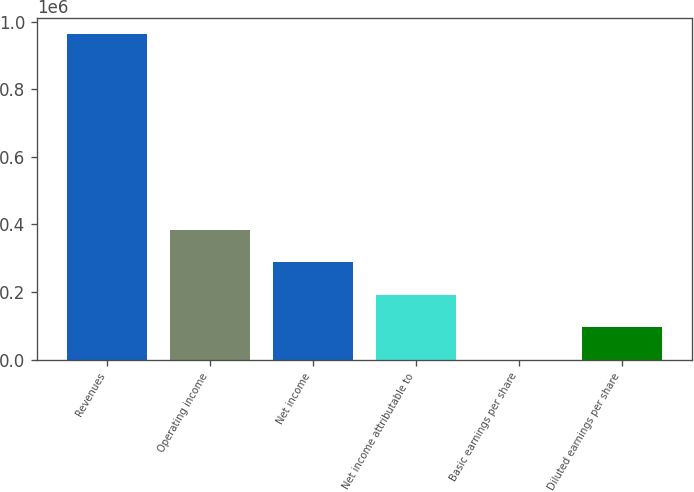Convert chart to OTSL. <chart><loc_0><loc_0><loc_500><loc_500><bar_chart><fcel>Revenues<fcel>Operating income<fcel>Net income<fcel>Net income attributable to<fcel>Basic earnings per share<fcel>Diluted earnings per share<nl><fcel>962240<fcel>384896<fcel>288672<fcel>192448<fcel>0.44<fcel>96224.4<nl></chart> 